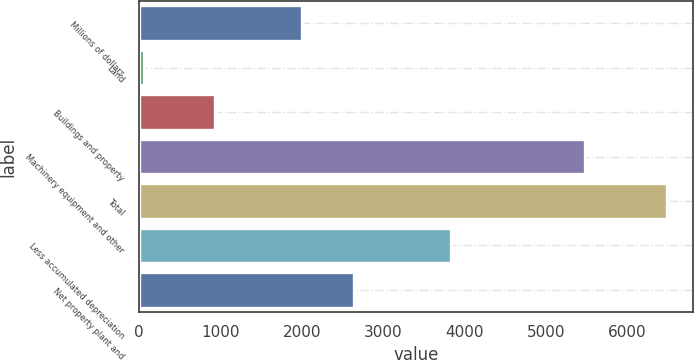Convert chart. <chart><loc_0><loc_0><loc_500><loc_500><bar_chart><fcel>Millions of dollars<fcel>Land<fcel>Buildings and property<fcel>Machinery equipment and other<fcel>Total<fcel>Less accumulated depreciation<fcel>Net property plant and<nl><fcel>2005<fcel>66<fcel>940<fcel>5480<fcel>6486<fcel>3838<fcel>2648<nl></chart> 